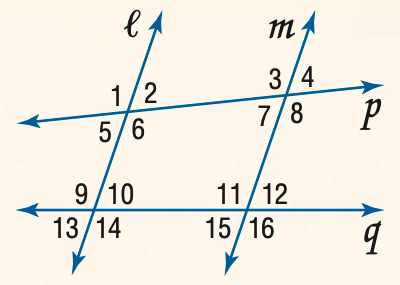Question: Find the measure of \angle 4 if l \parallel m and m \angle 1 = 105.
Choices:
A. 75
B. 85
C. 95
D. 105
Answer with the letter. Answer: A 